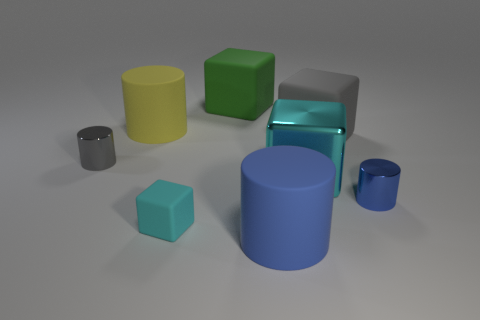What is the blue cylinder in front of the small blue shiny cylinder behind the rubber cylinder in front of the gray matte thing made of?
Your answer should be very brief. Rubber. Do the yellow object and the blue cylinder in front of the tiny cyan matte thing have the same material?
Your response must be concise. Yes. There is a big blue object that is the same shape as the gray metallic thing; what material is it?
Provide a succinct answer. Rubber. Is there any other thing that is made of the same material as the big blue cylinder?
Ensure brevity in your answer.  Yes. Is the number of cyan matte objects right of the small rubber object greater than the number of gray shiny cylinders behind the small blue metal cylinder?
Your response must be concise. No. What is the shape of the blue thing that is the same material as the big gray block?
Your response must be concise. Cylinder. What number of other things are there of the same shape as the green object?
Give a very brief answer. 3. There is a small metallic thing right of the gray cylinder; what is its shape?
Provide a succinct answer. Cylinder. What is the color of the small rubber block?
Your answer should be very brief. Cyan. How many other things are there of the same size as the cyan metallic block?
Ensure brevity in your answer.  4. 